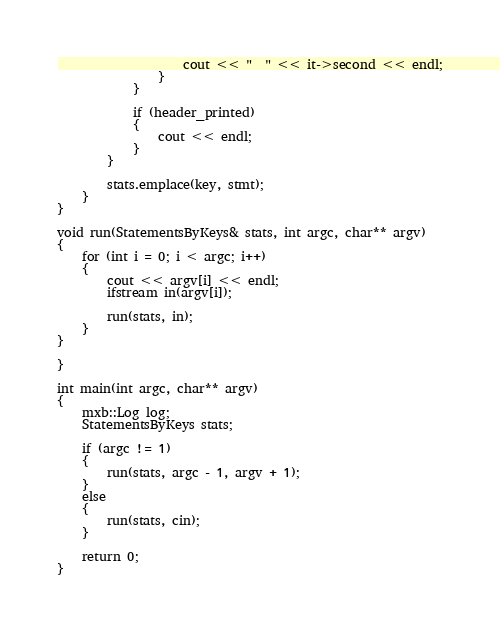<code> <loc_0><loc_0><loc_500><loc_500><_C++_>                    cout << "  " << it->second << endl;
                }
            }

            if (header_printed)
            {
                cout << endl;
            }
        }

        stats.emplace(key, stmt);
    }
}

void run(StatementsByKeys& stats, int argc, char** argv)
{
    for (int i = 0; i < argc; i++)
    {
        cout << argv[i] << endl;
        ifstream in(argv[i]);

        run(stats, in);
    }
}

}

int main(int argc, char** argv)
{
    mxb::Log log;
    StatementsByKeys stats;

    if (argc != 1)
    {
        run(stats, argc - 1, argv + 1);
    }
    else
    {
        run(stats, cin);
    }

    return 0;
}
</code> 